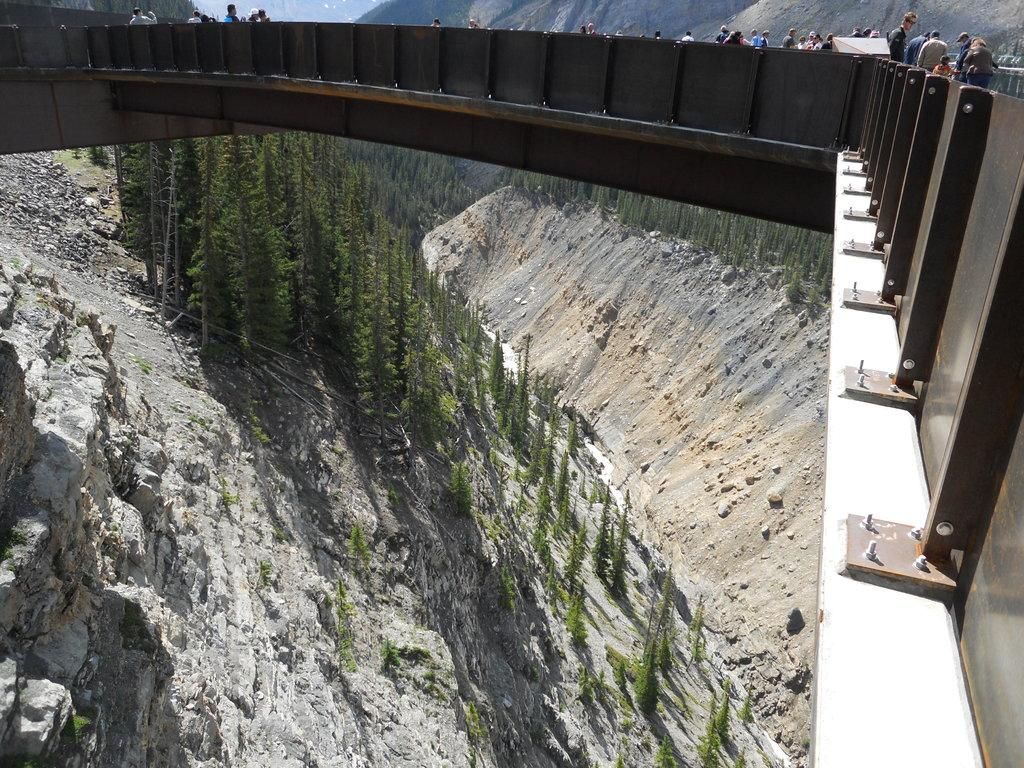What structure can be seen in the image? There is a bridge in the image. Are there any people on the bridge? Yes, there are people on the bridge. What can be seen at the bottom of the image? Mountains and trees are present at the bottom of the image. What type of news can be heard coming from the servant in the image? There is no servant or news present in the image. How many balls are visible in the image? There are no balls visible in the image. 